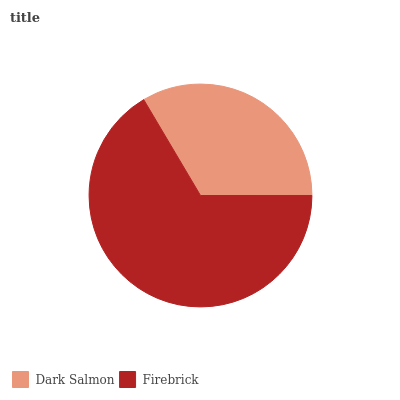Is Dark Salmon the minimum?
Answer yes or no. Yes. Is Firebrick the maximum?
Answer yes or no. Yes. Is Firebrick the minimum?
Answer yes or no. No. Is Firebrick greater than Dark Salmon?
Answer yes or no. Yes. Is Dark Salmon less than Firebrick?
Answer yes or no. Yes. Is Dark Salmon greater than Firebrick?
Answer yes or no. No. Is Firebrick less than Dark Salmon?
Answer yes or no. No. Is Firebrick the high median?
Answer yes or no. Yes. Is Dark Salmon the low median?
Answer yes or no. Yes. Is Dark Salmon the high median?
Answer yes or no. No. Is Firebrick the low median?
Answer yes or no. No. 